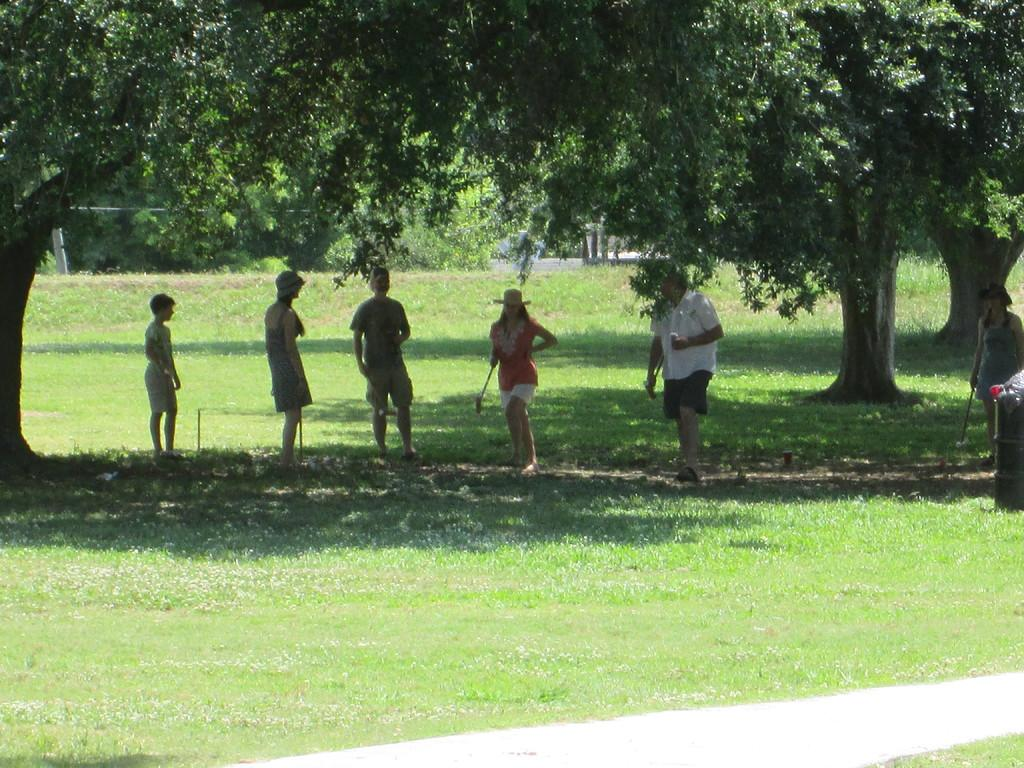Who or what can be seen in the image? There are people in the image. What type of natural environment is visible in the image? There is grass and trees in the image. What kind of feature is present for walking or traveling? There is a path in the image. What structure is present in the image? There is a pole in the image. Where are the objects located in the image? The objects are on the right side of the image. What type of drawer can be seen in the image? There is no drawer present in the image. Is there a lock visible on any of the objects in the image? There is no lock visible in the image. 